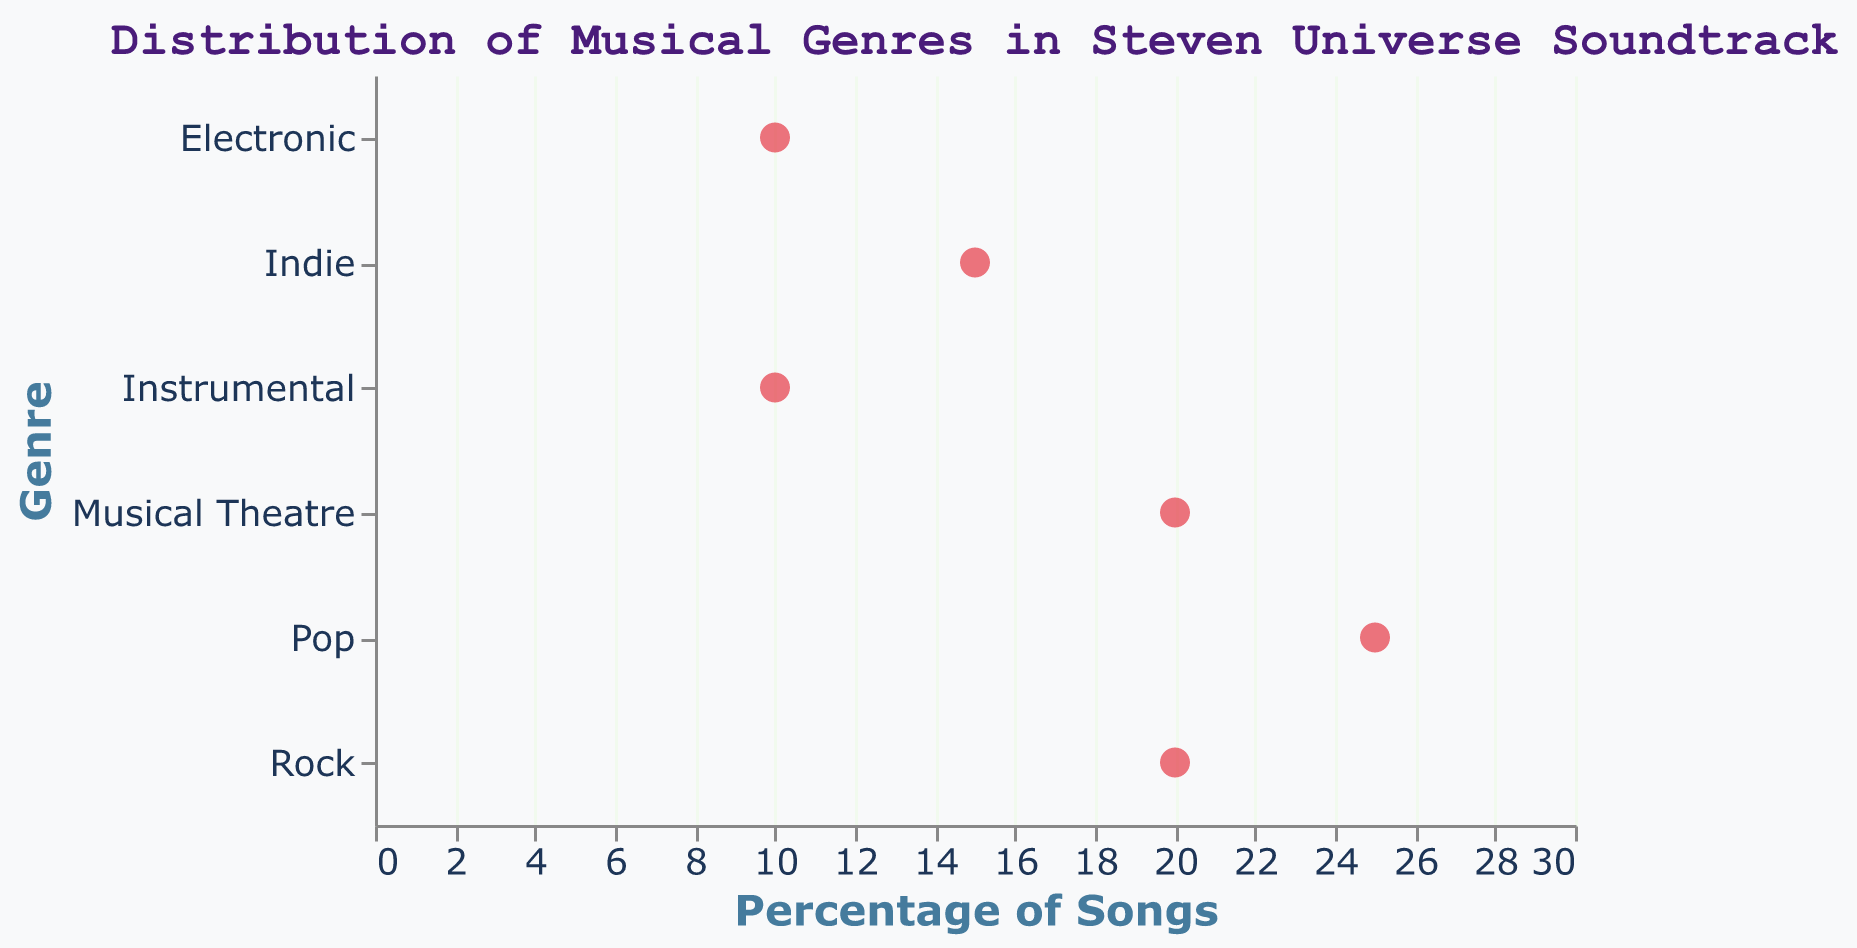What's the title of the figure? The title is clearly written at the top of the figure in a larger and different-colored font.
Answer: Distribution of Musical Genres in Steven Universe Soundtrack Which genre has the highest percentage of songs? By looking at the position of each dot along the x-axis, the dot representing "Pop" is the furthest to the right, indicating the highest percentage.
Answer: Pop How many genres are represented in the figure? Count the number of distinct genres listed on the y-axis of the plot.
Answer: 6 Which two genres have the same percentage of songs? By observing the position of the dots along the x-axis, "Rock" and "Musical Theatre" both have dots aligned with the 20% mark.
Answer: Rock and Musical Theatre What's the total percentage of songs for genres with the lowest percentage? Add the percentages of the genres with the lowest percentage, which are "Electronic" and "Instrumental," each at 10%.
Answer: 20% Is the percentage of Indie songs greater than that of Instrumental songs? Compare the positions of the dots for "Indie" and "Instrumental" along the x-axis: "Indie" is at 15%, and "Instrumental" is at 10%.
Answer: Yes What’s the average percentage of songs in all genres? Add all the percentages and divide by the number of genres: (25 + 20 + 15 + 10 + 20 + 10) / 6 = 100 / 6 ≈ 16.67%.
Answer: 16.67% Which genre appears in the middle in terms of percentage when sorted in ascending order? Sorting the percentages (10, 10, 15, 20, 20, 25) and finding the middle value(s), which are 15% and 20%.
Answer: Indie or Rock/Musical Theatre How much more represented is the Pop genre compared to the Electronic genre? Subtract the percentage of Electronic from the percentage of Pop: 25% - 10% = 15%.
Answer: 15% What's the difference in the number of songs between the genres with the highest and lowest percentages? Since there’s no information on the total number of songs, we can only provide the percentage difference: 25% (Pop) - 10% (Electronic/Instrumental) = 15%.
Answer: 15% 